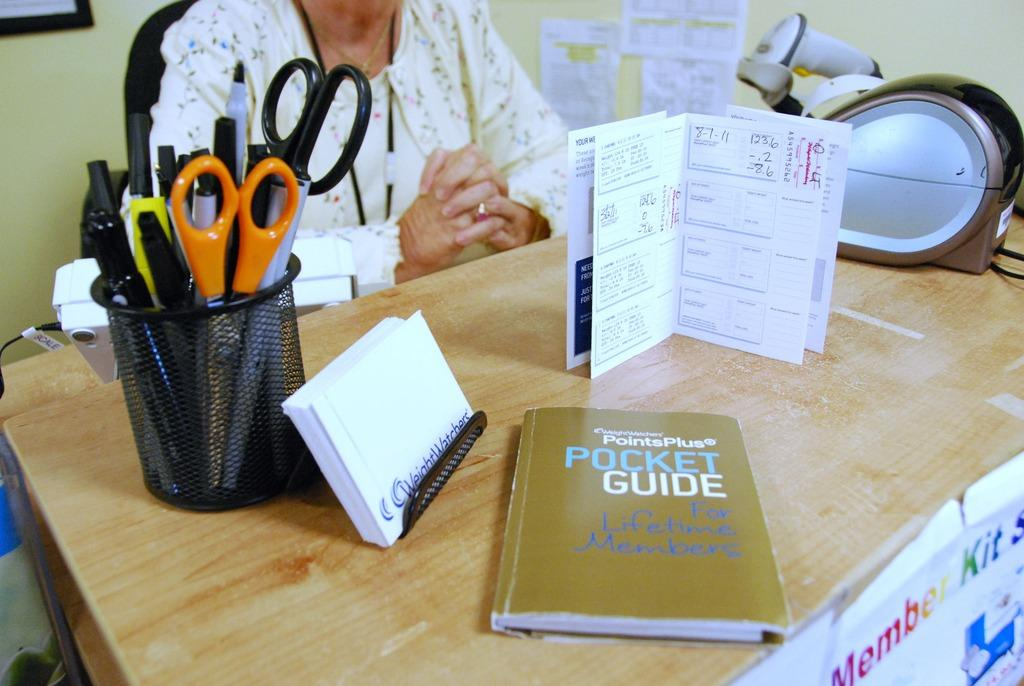<image>
Present a compact description of the photo's key features. a book titled 'pocket guide for lifetime members' 